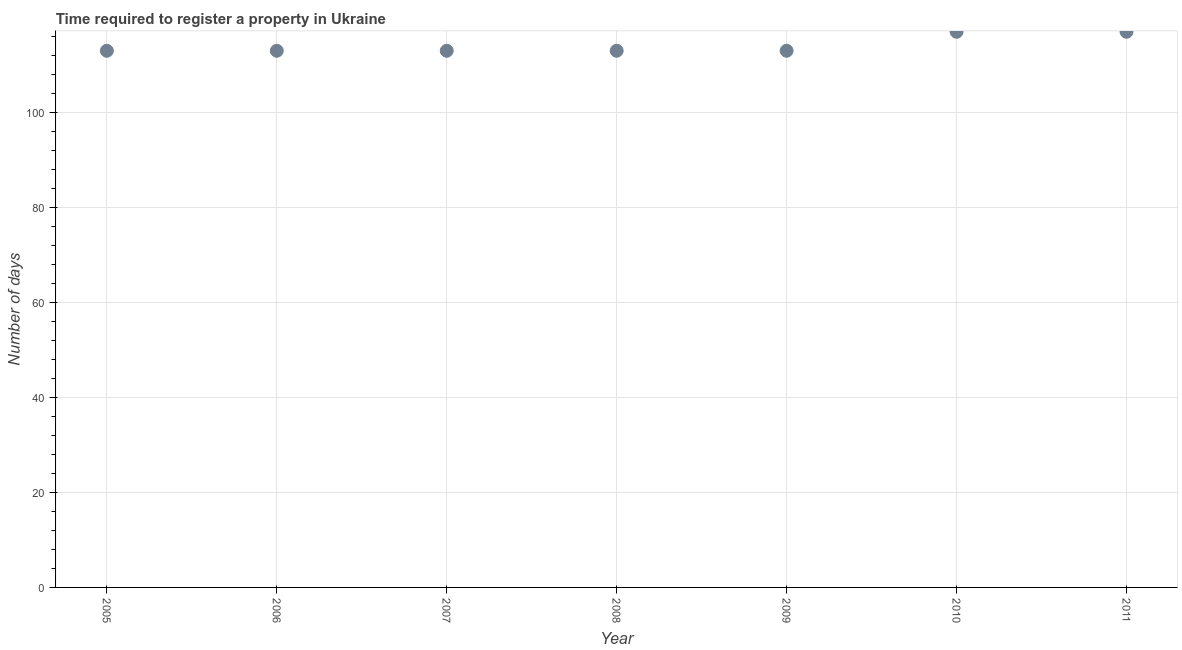What is the number of days required to register property in 2005?
Ensure brevity in your answer.  113. Across all years, what is the maximum number of days required to register property?
Offer a terse response. 117. Across all years, what is the minimum number of days required to register property?
Your answer should be compact. 113. In which year was the number of days required to register property minimum?
Ensure brevity in your answer.  2005. What is the sum of the number of days required to register property?
Keep it short and to the point. 799. What is the difference between the number of days required to register property in 2006 and 2009?
Your response must be concise. 0. What is the average number of days required to register property per year?
Your answer should be very brief. 114.14. What is the median number of days required to register property?
Your response must be concise. 113. What is the difference between the highest and the second highest number of days required to register property?
Your answer should be compact. 0. Is the sum of the number of days required to register property in 2009 and 2010 greater than the maximum number of days required to register property across all years?
Offer a very short reply. Yes. What is the difference between the highest and the lowest number of days required to register property?
Offer a terse response. 4. In how many years, is the number of days required to register property greater than the average number of days required to register property taken over all years?
Offer a terse response. 2. Does the number of days required to register property monotonically increase over the years?
Your answer should be very brief. No. Does the graph contain any zero values?
Give a very brief answer. No. What is the title of the graph?
Offer a terse response. Time required to register a property in Ukraine. What is the label or title of the X-axis?
Your answer should be very brief. Year. What is the label or title of the Y-axis?
Your response must be concise. Number of days. What is the Number of days in 2005?
Keep it short and to the point. 113. What is the Number of days in 2006?
Give a very brief answer. 113. What is the Number of days in 2007?
Provide a short and direct response. 113. What is the Number of days in 2008?
Ensure brevity in your answer.  113. What is the Number of days in 2009?
Make the answer very short. 113. What is the Number of days in 2010?
Provide a succinct answer. 117. What is the Number of days in 2011?
Make the answer very short. 117. What is the difference between the Number of days in 2005 and 2008?
Provide a short and direct response. 0. What is the difference between the Number of days in 2005 and 2011?
Make the answer very short. -4. What is the difference between the Number of days in 2006 and 2008?
Offer a terse response. 0. What is the difference between the Number of days in 2007 and 2009?
Ensure brevity in your answer.  0. What is the difference between the Number of days in 2007 and 2011?
Offer a very short reply. -4. What is the difference between the Number of days in 2008 and 2009?
Give a very brief answer. 0. What is the difference between the Number of days in 2008 and 2010?
Make the answer very short. -4. What is the difference between the Number of days in 2009 and 2011?
Make the answer very short. -4. What is the difference between the Number of days in 2010 and 2011?
Your response must be concise. 0. What is the ratio of the Number of days in 2005 to that in 2006?
Your response must be concise. 1. What is the ratio of the Number of days in 2005 to that in 2009?
Ensure brevity in your answer.  1. What is the ratio of the Number of days in 2005 to that in 2011?
Your answer should be compact. 0.97. What is the ratio of the Number of days in 2007 to that in 2009?
Provide a succinct answer. 1. What is the ratio of the Number of days in 2007 to that in 2010?
Provide a short and direct response. 0.97. What is the ratio of the Number of days in 2007 to that in 2011?
Offer a very short reply. 0.97. What is the ratio of the Number of days in 2009 to that in 2010?
Provide a succinct answer. 0.97. What is the ratio of the Number of days in 2009 to that in 2011?
Your response must be concise. 0.97. What is the ratio of the Number of days in 2010 to that in 2011?
Offer a very short reply. 1. 